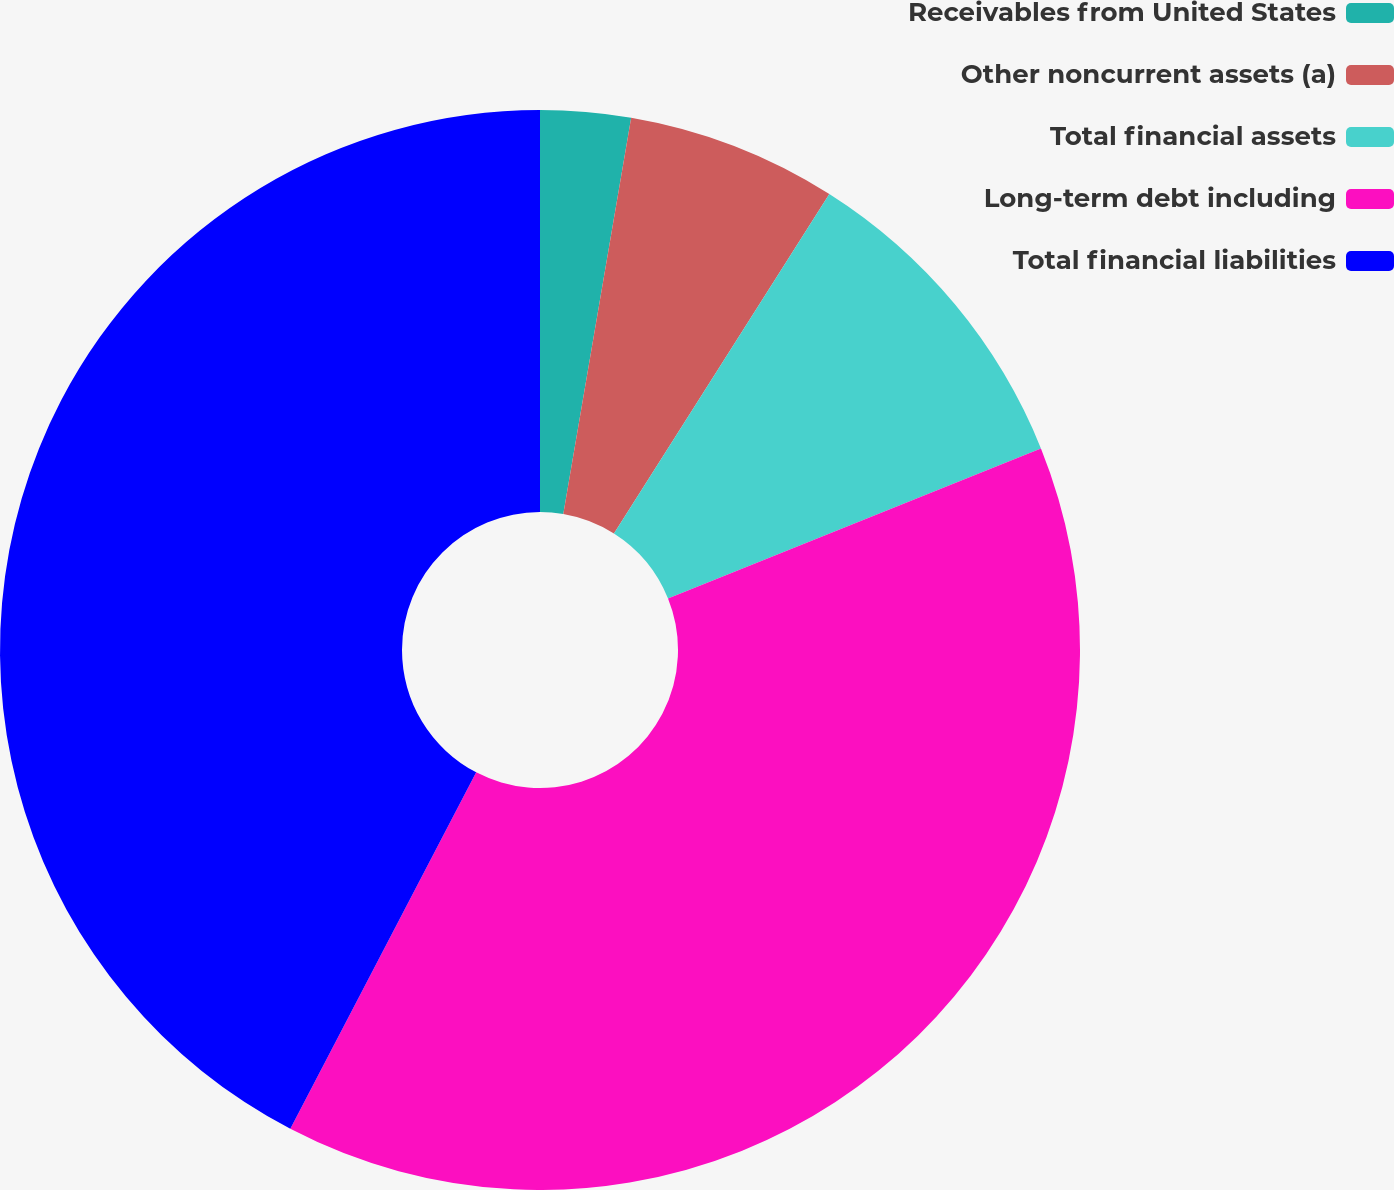Convert chart. <chart><loc_0><loc_0><loc_500><loc_500><pie_chart><fcel>Receivables from United States<fcel>Other noncurrent assets (a)<fcel>Total financial assets<fcel>Long-term debt including<fcel>Total financial liabilities<nl><fcel>2.7%<fcel>6.3%<fcel>9.91%<fcel>38.74%<fcel>42.35%<nl></chart> 